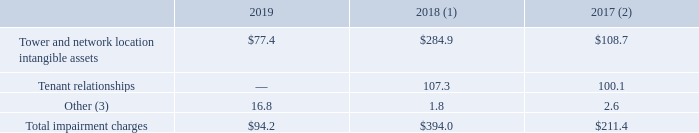AMERICAN TOWER CORPORATION AND SUBSIDIARIES NOTES TO CONSOLIDATED FINANCIAL STATEMENTS (Tabular amounts in millions, unless otherwise disclosed)
17. OTHER OPERATING EXPENSE
Other operating expense consists primarily of impairment charges, net losses on sales or disposals of assets and other operating expense items. The Company records impairment charges to write down certain assets to their net realizable value after an indicator of impairment is identified and subsequent analysis determines that the asset is either partially recoverable or not recoverable. These assets consisted primarily of towers and related assets, which are typically assessed on an individual basis, network location intangibles, which relate directly to towers, and tenant-related intangibles, which are assessed on a tenant basis. Net losses on sales or disposals of assets primarily relate to certain non-core towers, other assets and miscellaneous items. Other operating expenses includes acquisition-related costs and integration costs.
Impairment charges included the following for the years ended December 31,:
(1) For the year ended December 31, 2018, impairment charges on tower and network location intangible assets included $258.3 million in India primarily related to carrier consolidation-driven churn events. In addition, the Company fully impaired the tenant relationship for Aircel Ltd., which resulted in an impairment charge of $107.3 million.
(2) During the year ended December 31, 2017, $81.0 million of impairment charges on tower and network location intangible assets and all impairment charges on tenant relationships were related to carrier consolidation-driven churn in India.
(3) For the year ended December 31, 2019, amount includes impairment charges related to right-of-use assets and land easements.
For the year ended December 31, 2019, what did the amount in Other include? Impairment charges related to right-of-use assets and land easements. How much were the total impairment charges in 2017?
Answer scale should be: million. $211.4. What were the Tower and network location intangible assets in 2019?
Answer scale should be: million. $77.4. How many years were the total impairment charges above $200 million? 2018##2017
Answer: 2. How many years were the Tower and network location intangible assets above $100 million? 2018##2017
Answer: 2. What was the percentage change in Total impairment charges between 2018 and 2019?
Answer scale should be: percent. ($94.2-$394.0)/$394.0
Answer: -76.09. 